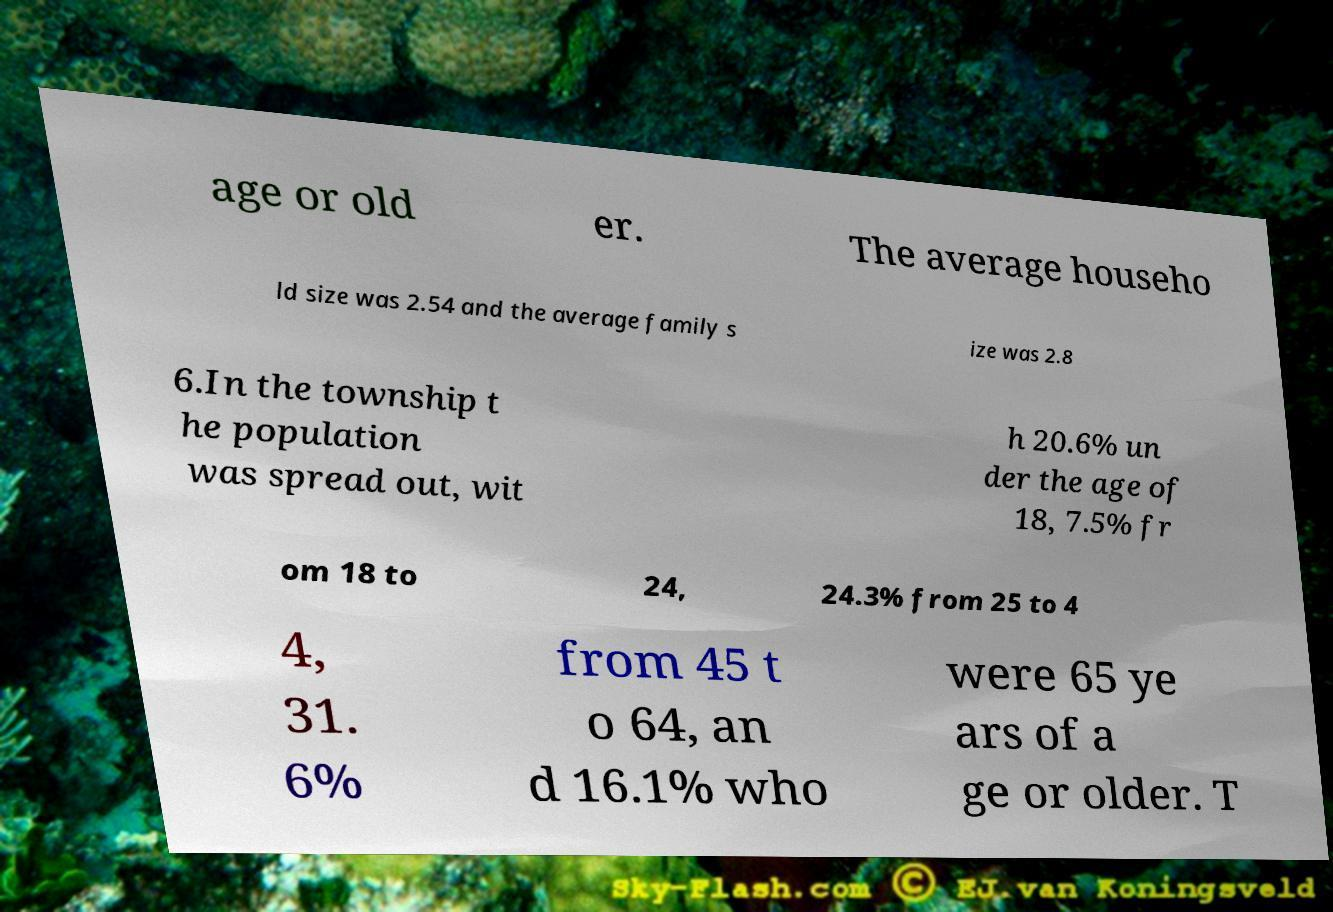What messages or text are displayed in this image? I need them in a readable, typed format. age or old er. The average househo ld size was 2.54 and the average family s ize was 2.8 6.In the township t he population was spread out, wit h 20.6% un der the age of 18, 7.5% fr om 18 to 24, 24.3% from 25 to 4 4, 31. 6% from 45 t o 64, an d 16.1% who were 65 ye ars of a ge or older. T 